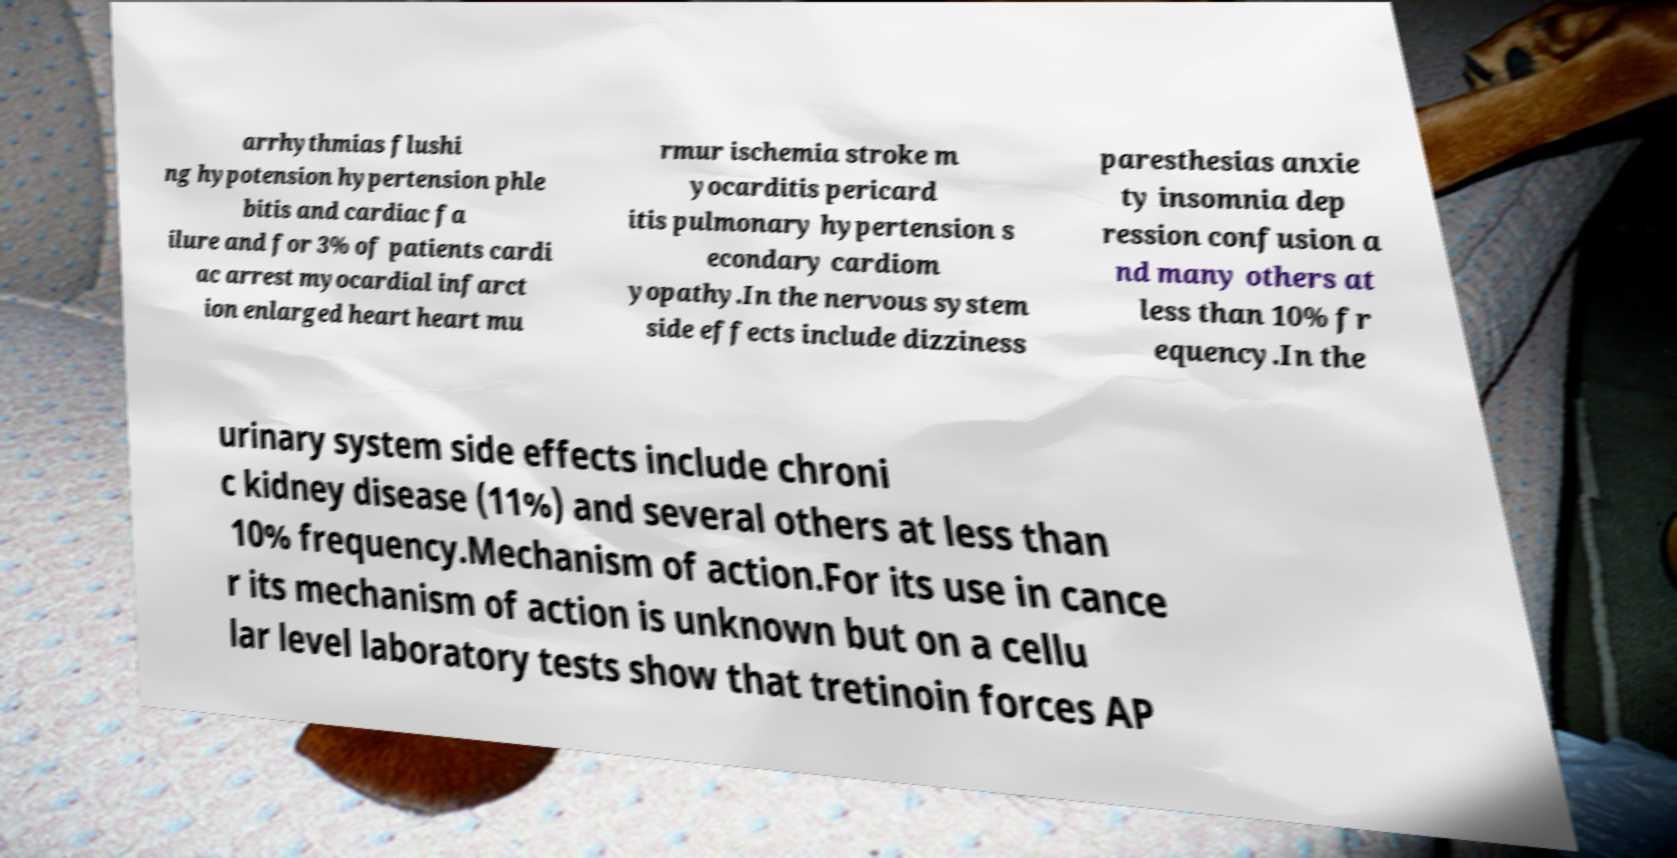Please identify and transcribe the text found in this image. arrhythmias flushi ng hypotension hypertension phle bitis and cardiac fa ilure and for 3% of patients cardi ac arrest myocardial infarct ion enlarged heart heart mu rmur ischemia stroke m yocarditis pericard itis pulmonary hypertension s econdary cardiom yopathy.In the nervous system side effects include dizziness paresthesias anxie ty insomnia dep ression confusion a nd many others at less than 10% fr equency.In the urinary system side effects include chroni c kidney disease (11%) and several others at less than 10% frequency.Mechanism of action.For its use in cance r its mechanism of action is unknown but on a cellu lar level laboratory tests show that tretinoin forces AP 